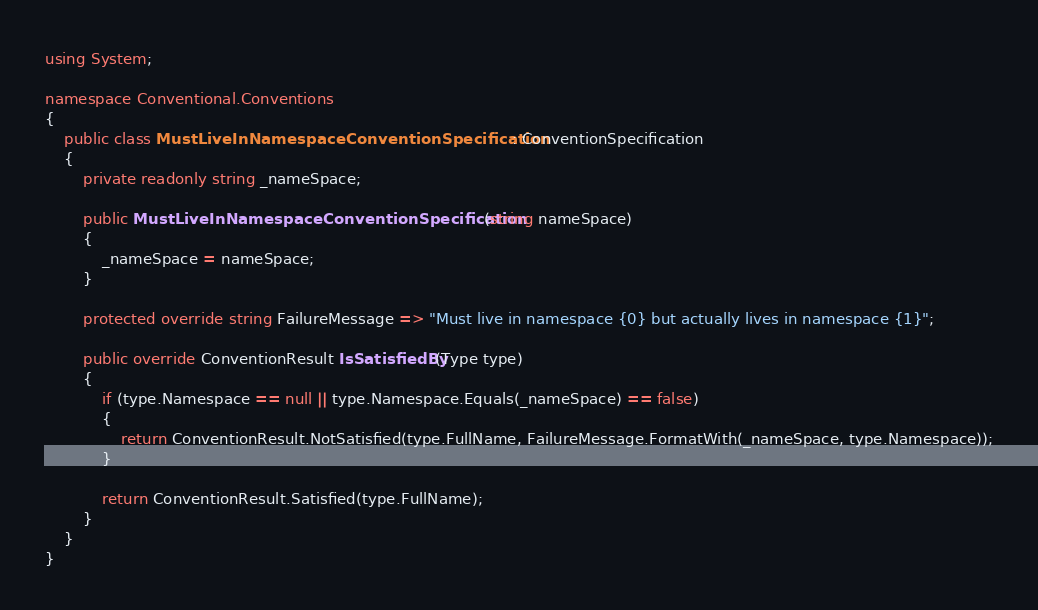<code> <loc_0><loc_0><loc_500><loc_500><_C#_>using System;

namespace Conventional.Conventions
{
    public class MustLiveInNamespaceConventionSpecification : ConventionSpecification
    {
        private readonly string _nameSpace;

        public MustLiveInNamespaceConventionSpecification(string nameSpace)
        {
            _nameSpace = nameSpace;
        }

        protected override string FailureMessage => "Must live in namespace {0} but actually lives in namespace {1}";

        public override ConventionResult IsSatisfiedBy(Type type)
        {
            if (type.Namespace == null || type.Namespace.Equals(_nameSpace) == false)
            {
                return ConventionResult.NotSatisfied(type.FullName, FailureMessage.FormatWith(_nameSpace, type.Namespace));
            }

            return ConventionResult.Satisfied(type.FullName);
        }
    }
}</code> 